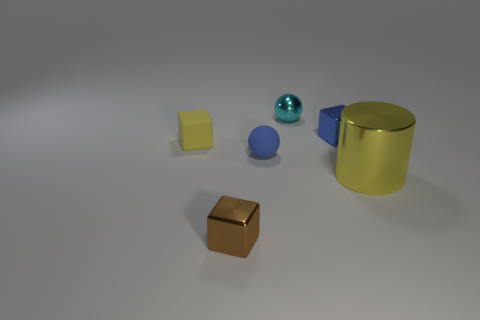There is a cube that is right of the block that is in front of the sphere in front of the cyan sphere; what is its size?
Your answer should be compact. Small. Does the big metallic object have the same shape as the small shiny thing in front of the yellow metal object?
Keep it short and to the point. No. What number of yellow objects are right of the tiny yellow block and on the left side of the large metal cylinder?
Your answer should be compact. 0. What number of blue things are either rubber objects or big cylinders?
Ensure brevity in your answer.  1. There is a tiny rubber thing that is on the left side of the small matte sphere; does it have the same color as the large cylinder in front of the cyan metallic thing?
Your answer should be compact. Yes. The small block that is in front of the tiny rubber object that is on the left side of the tiny shiny thing that is in front of the large yellow object is what color?
Offer a very short reply. Brown. There is a rubber sphere behind the tiny brown metal block; are there any metal spheres that are in front of it?
Provide a short and direct response. No. There is a thing that is behind the blue shiny cube; is it the same shape as the blue matte thing?
Give a very brief answer. Yes. Is there any other thing that is the same shape as the large yellow metal object?
Make the answer very short. No. How many blocks are tiny yellow objects or small cyan things?
Give a very brief answer. 1. 